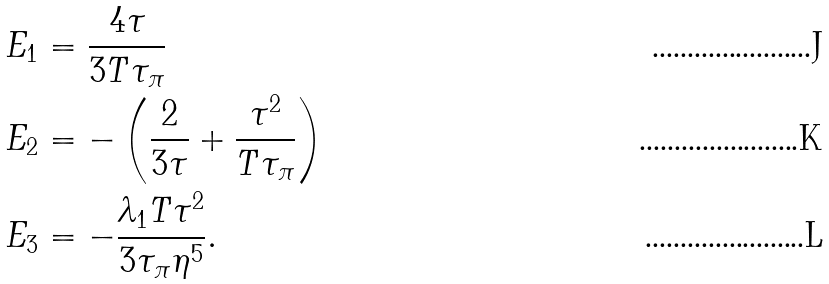Convert formula to latex. <formula><loc_0><loc_0><loc_500><loc_500>E _ { 1 } & = \frac { 4 \tau } { 3 T \tau _ { \pi } } \\ E _ { 2 } & = - \left ( \frac { 2 } { 3 \tau } + \frac { \tau ^ { 2 } } { T \tau _ { \pi } } \right ) \\ E _ { 3 } & = - \frac { \lambda _ { 1 } T \tau ^ { 2 } } { 3 \tau _ { \pi } \eta ^ { 5 } } .</formula> 